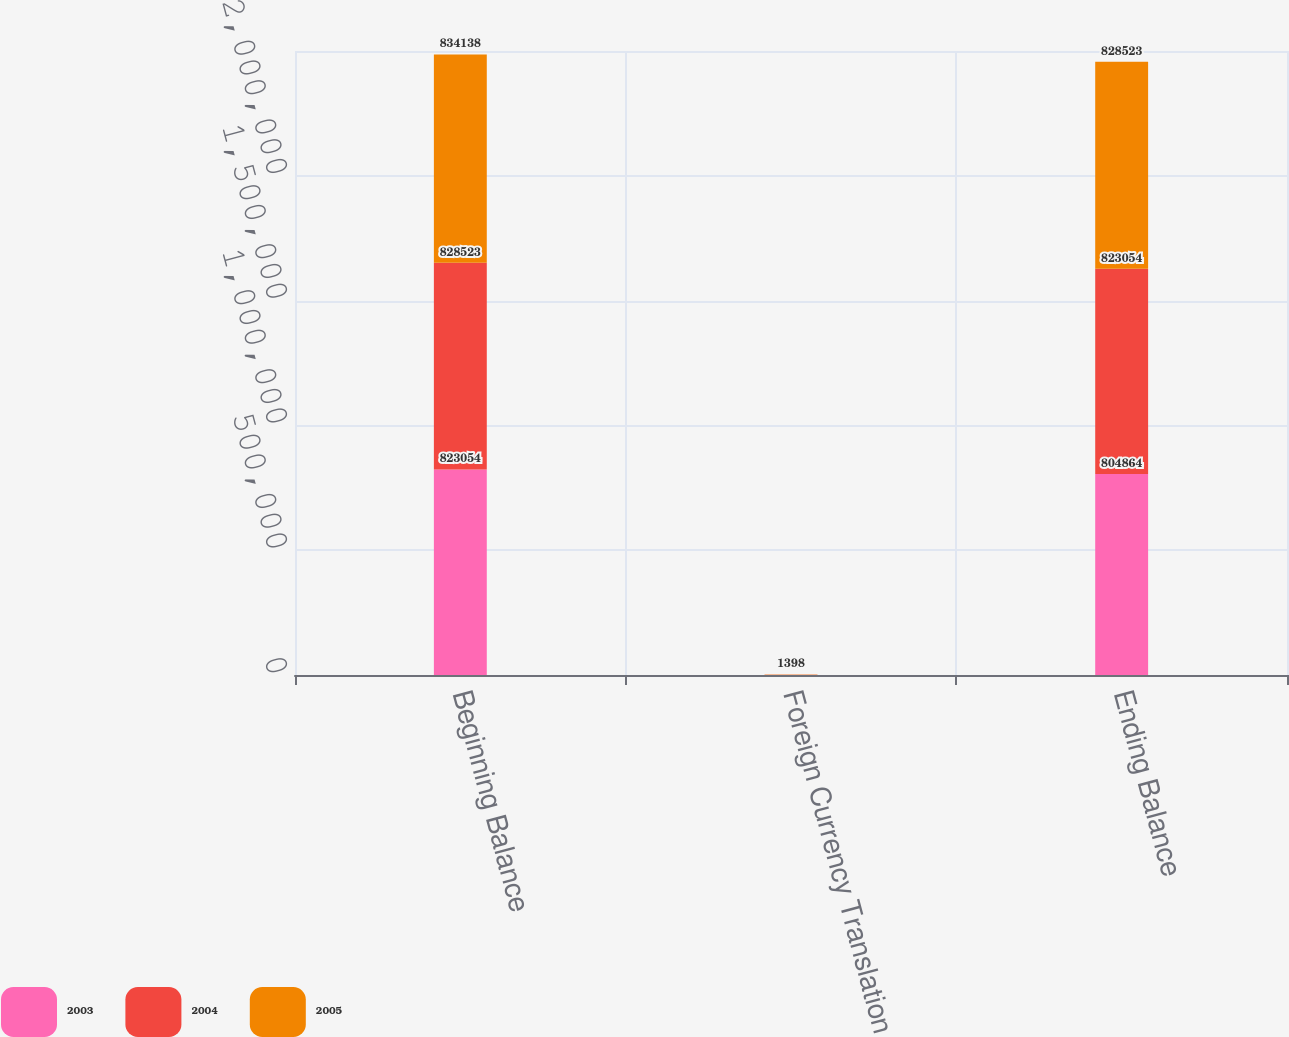<chart> <loc_0><loc_0><loc_500><loc_500><stacked_bar_chart><ecel><fcel>Beginning Balance<fcel>Foreign Currency Translation<fcel>Ending Balance<nl><fcel>2003<fcel>823054<fcel>246<fcel>804864<nl><fcel>2004<fcel>828523<fcel>571<fcel>823054<nl><fcel>2005<fcel>834138<fcel>1398<fcel>828523<nl></chart> 